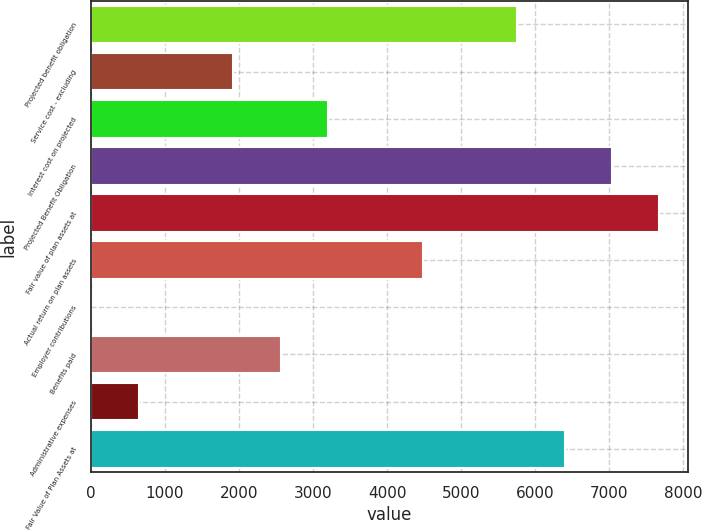Convert chart to OTSL. <chart><loc_0><loc_0><loc_500><loc_500><bar_chart><fcel>Projected benefit obligation<fcel>Service cost - excluding<fcel>Interest cost on projected<fcel>Projected Benefit Obligation<fcel>Fair value of plan assets at<fcel>Actual return on plan assets<fcel>Employer contributions<fcel>Benefits paid<fcel>Administrative expenses<fcel>Fair Value of Plan Assets at<nl><fcel>5757.5<fcel>1920.5<fcel>3199.5<fcel>7036.5<fcel>7676<fcel>4478.5<fcel>2<fcel>2560<fcel>641.5<fcel>6397<nl></chart> 